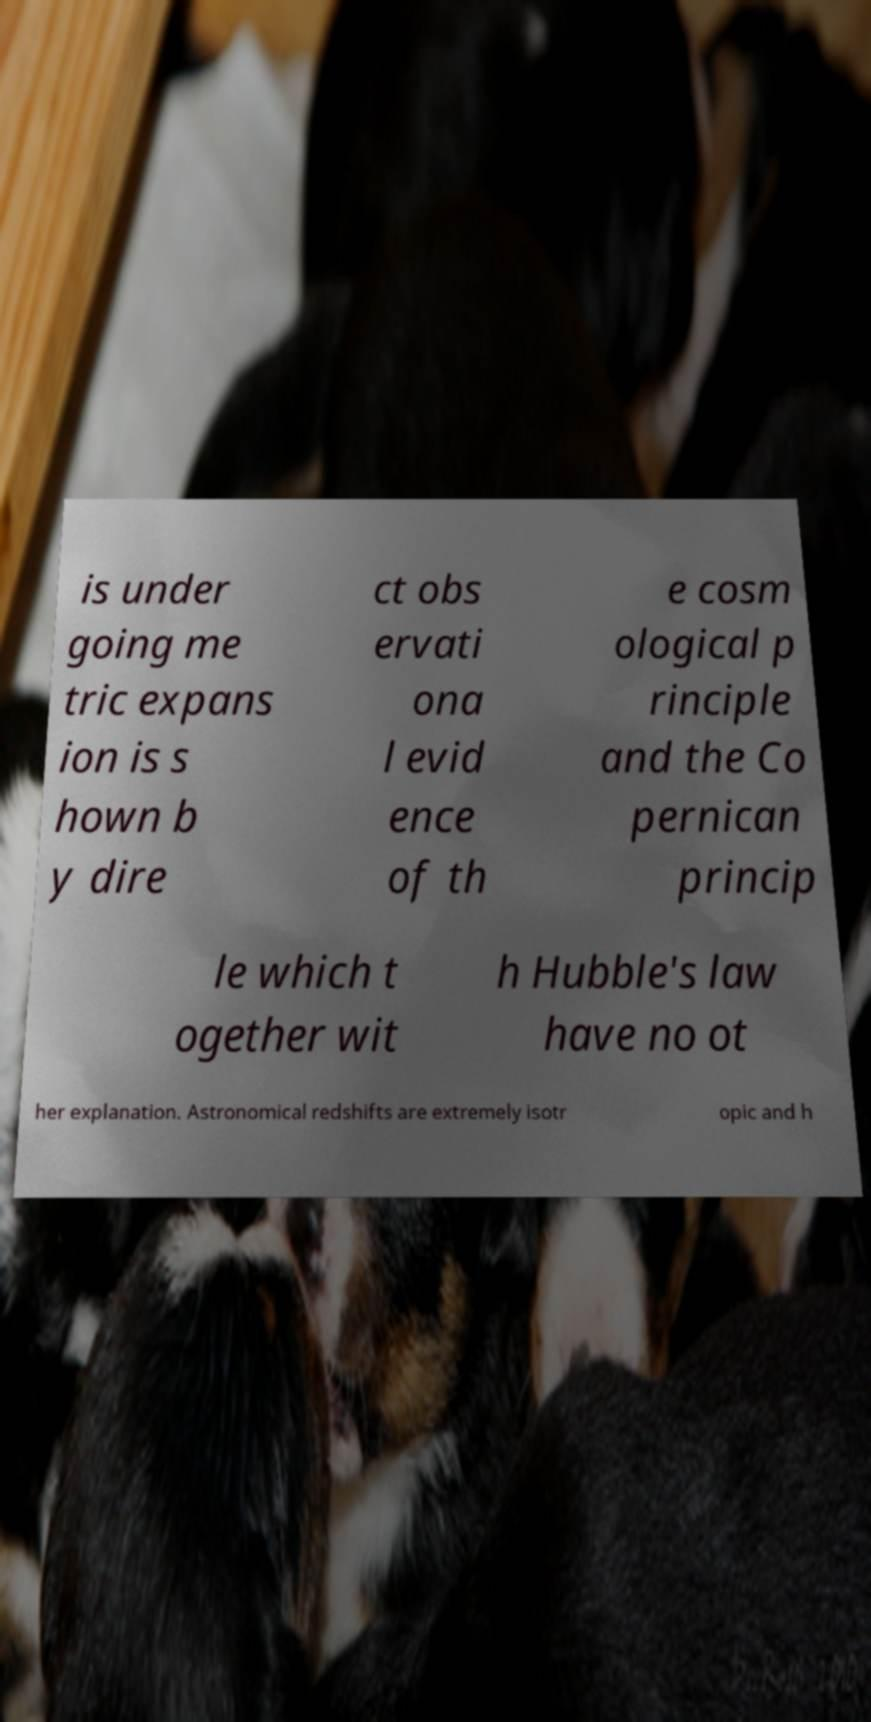There's text embedded in this image that I need extracted. Can you transcribe it verbatim? is under going me tric expans ion is s hown b y dire ct obs ervati ona l evid ence of th e cosm ological p rinciple and the Co pernican princip le which t ogether wit h Hubble's law have no ot her explanation. Astronomical redshifts are extremely isotr opic and h 